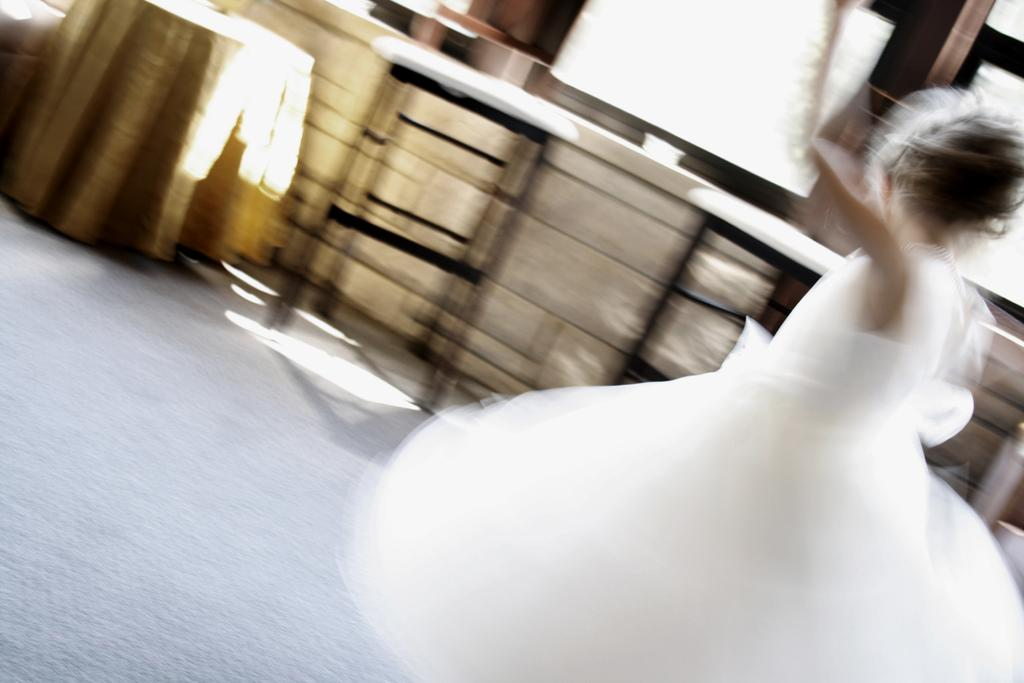Who or what is on the right side of the image? There is a person standing on the right side of the image. What can be seen at the top of the image? At the top of the image, there is a table, a cloth, a chair, and a window. What is the surface that the person is standing on? The floor is present at the bottom of the image. How many ladybugs are crawling on the person's chin in the image? There are no ladybugs present in the image, and therefore no such activity can be observed. 